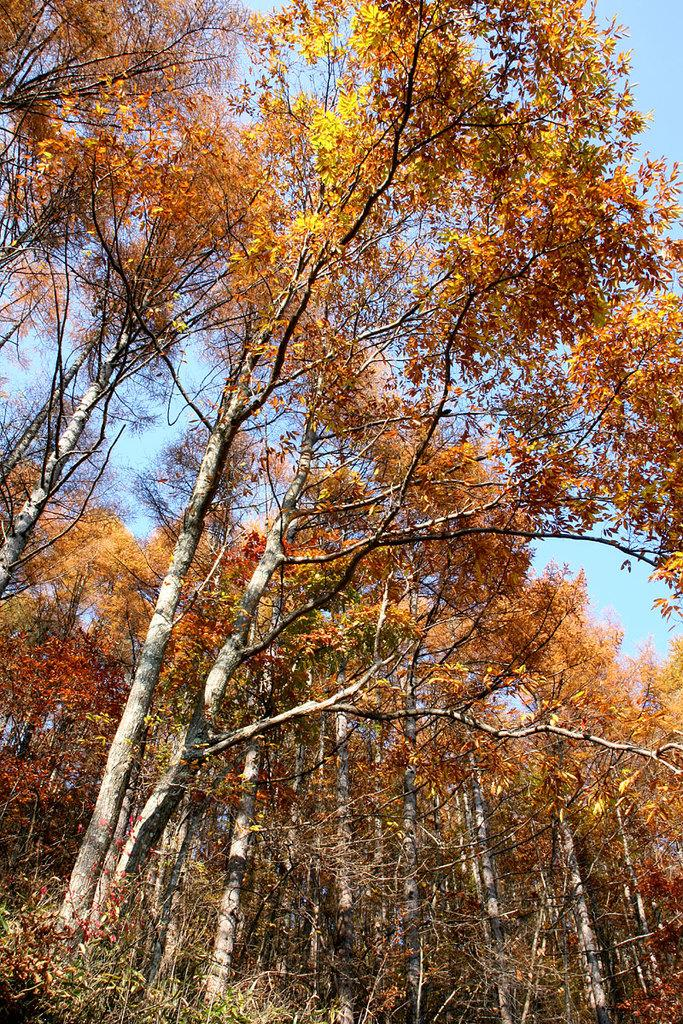What type of trees are present in the image? The trees in the image have yellow leaves. What other vegetation can be seen in the image? There is grass visible in the image. What day of the week is depicted in the image? The image does not depict a specific day of the week; it only shows trees with yellow leaves and grass. 